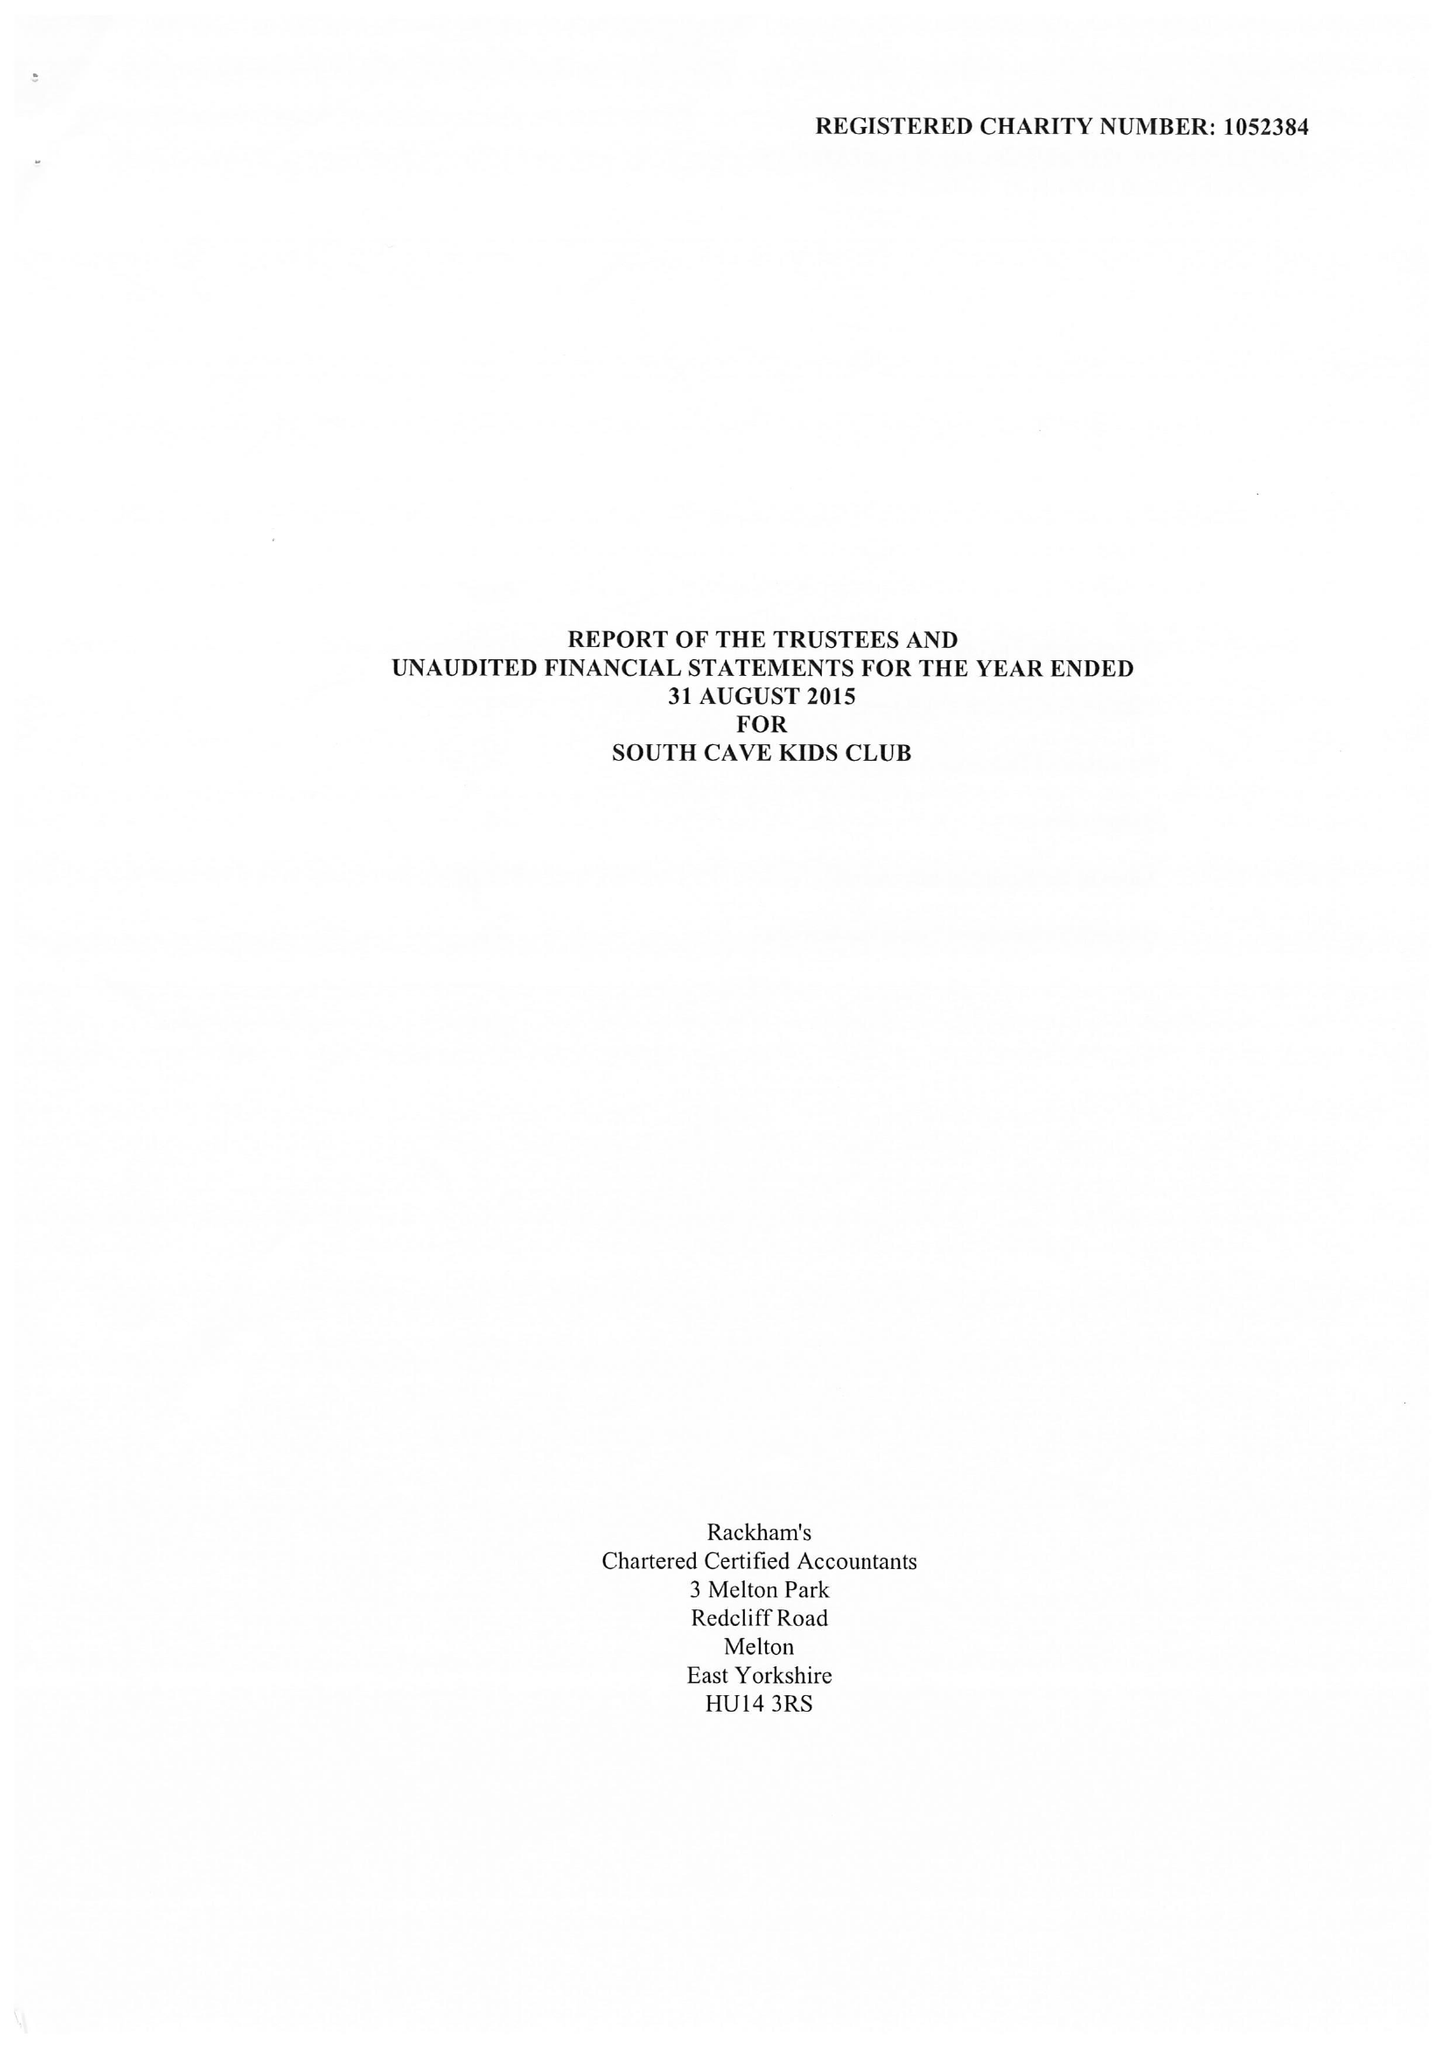What is the value for the spending_annually_in_british_pounds?
Answer the question using a single word or phrase. 92186.00 